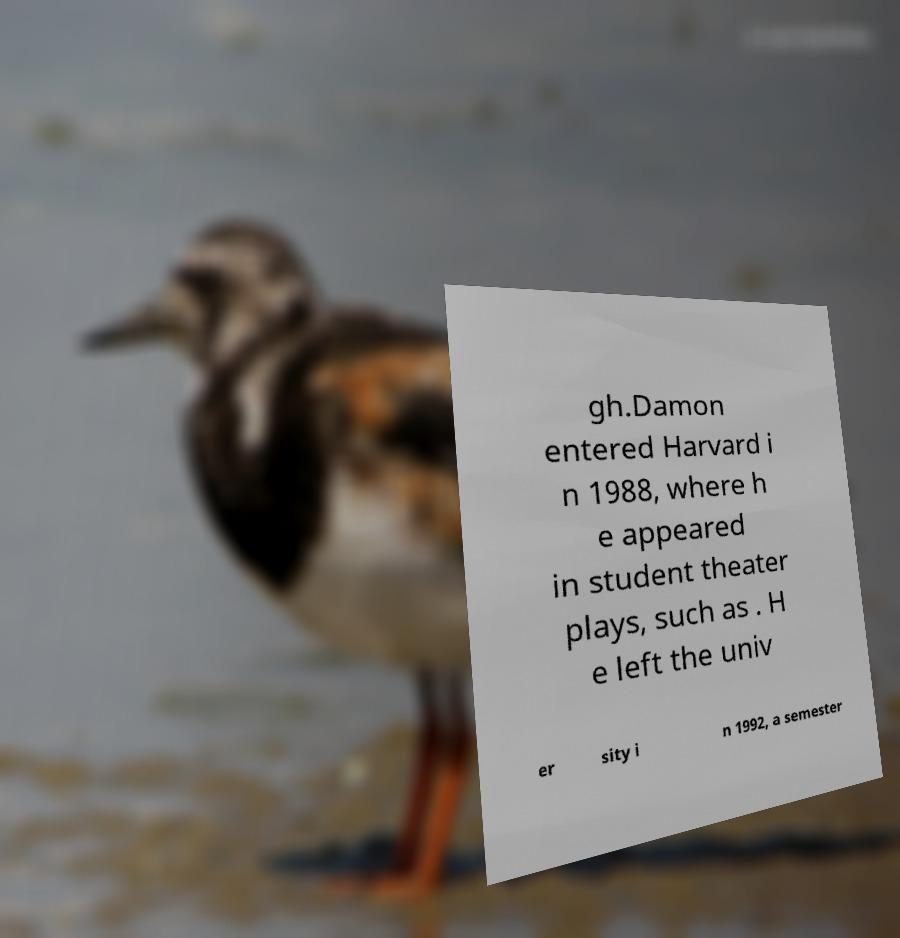Please identify and transcribe the text found in this image. gh.Damon entered Harvard i n 1988, where h e appeared in student theater plays, such as . H e left the univ er sity i n 1992, a semester 